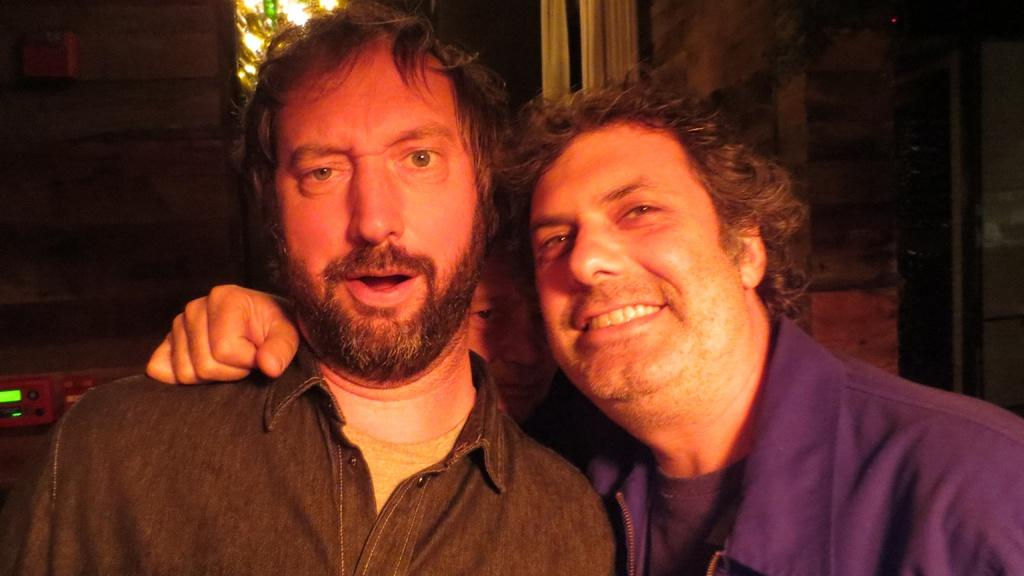How many people are present in the image? There are two people in the image. Can you describe the arrangement of the people? There is a person visible between the two people. What is located on the left side of the image? There is a machine on the left side of the image. What can be seen in the background of the image? The background of the image includes light and a wall. What type of kitten can be seen playing with a bomb in the image? There is no kitten or bomb present in the image; it only features two people, a person between them, a machine, and a background with light and a wall. 